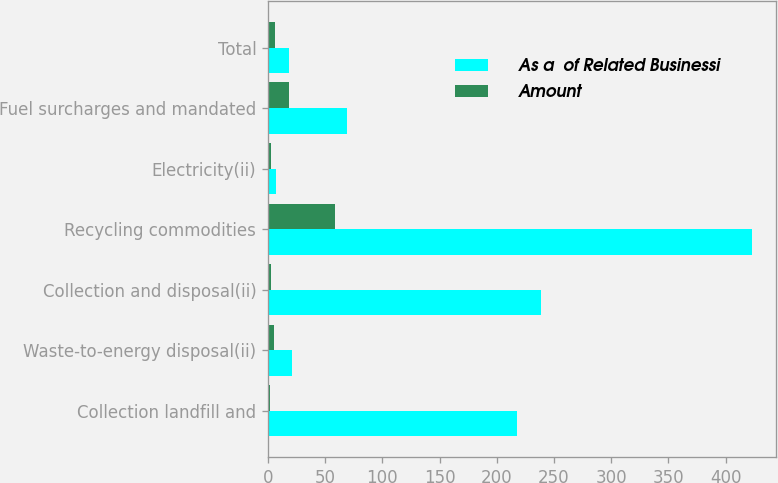Convert chart to OTSL. <chart><loc_0><loc_0><loc_500><loc_500><stacked_bar_chart><ecel><fcel>Collection landfill and<fcel>Waste-to-energy disposal(ii)<fcel>Collection and disposal(ii)<fcel>Recycling commodities<fcel>Electricity(ii)<fcel>Fuel surcharges and mandated<fcel>Total<nl><fcel>As a  of Related Businessi<fcel>218<fcel>21<fcel>239<fcel>423<fcel>7<fcel>69<fcel>18.4<nl><fcel>Amount<fcel>2.2<fcel>5.1<fcel>2.3<fcel>58.5<fcel>2.5<fcel>18.4<fcel>6.1<nl></chart> 